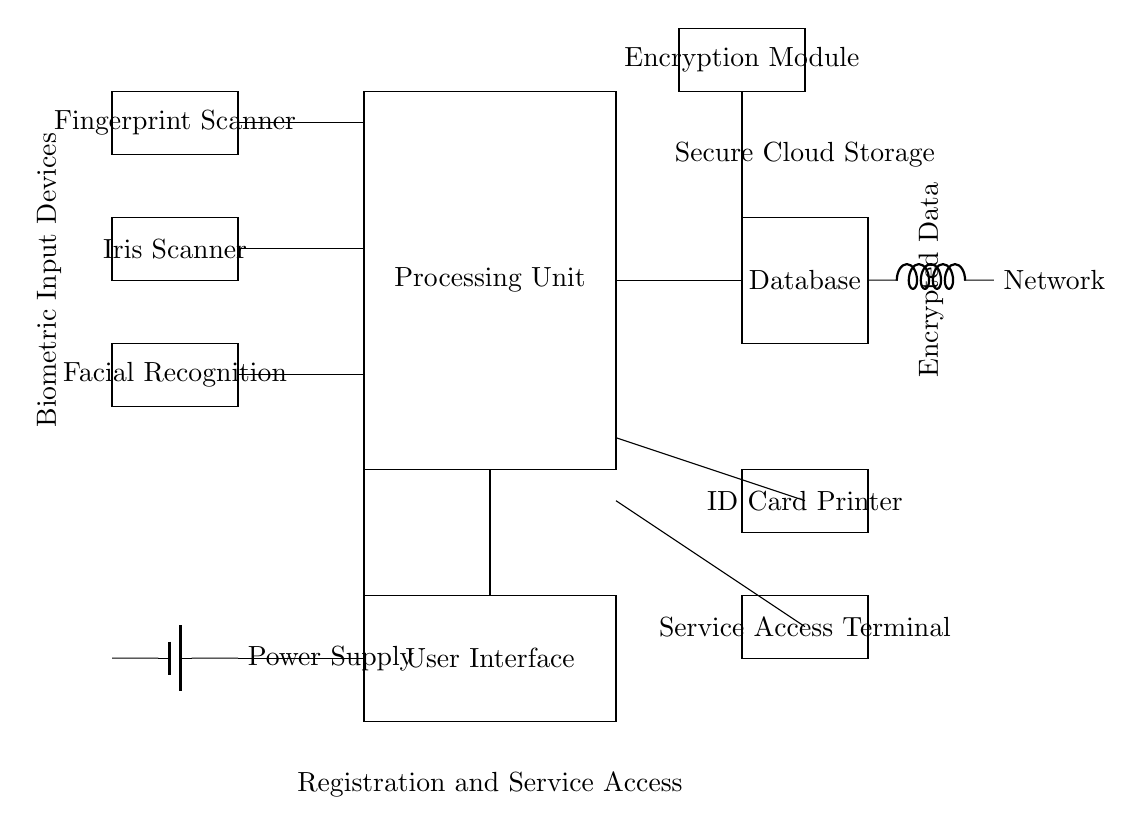What are the primary biometric input devices? The circuit diagram shows three primary biometric input devices, which are the fingerprint scanner, iris scanner, and facial recognition system. These are labeled on the left side of the diagram.
Answer: Fingerprint scanner, iris scanner, facial recognition How many main components are there in the processing unit? The processing unit is represented as a rectangle in the circuit. There are no additional sub-components shown within this rectangle, meaning it functions as a whole.
Answer: One What is the purpose of the encryption module? The encryption module is indicated at the top right of the diagram and is responsible for securing the data being processed and transferred, ensuring that the biometric data is encrypted before sending it to the database.
Answer: Secure data Which device outputs the physical identification? The ID card printer is shown towards the lower right section of the circuit diagram, enabling the physical output of the identification cards for registered users.
Answer: ID card printer What is the connection type between the database and the network? The connection type in the diagram is represented by a cute inductor symbol, which indicates that the database is connected to the network for data transfer and communication purposes.
Answer: Network How are biometric data inputs being processed? The biometric input devices (fingerprint scanner, iris scanner, facial recognition) are all connected to the processing unit, indicating that data gathered from these inputs are sent to this unit for analysis and processing.
Answer: Through the processing unit Where is the user interface located in the circuit? The user interface is shown as a rectangle located below the processing unit. It connects to the processing unit for user interactions and input management, indicating its position in the system.
Answer: Below the processing unit 